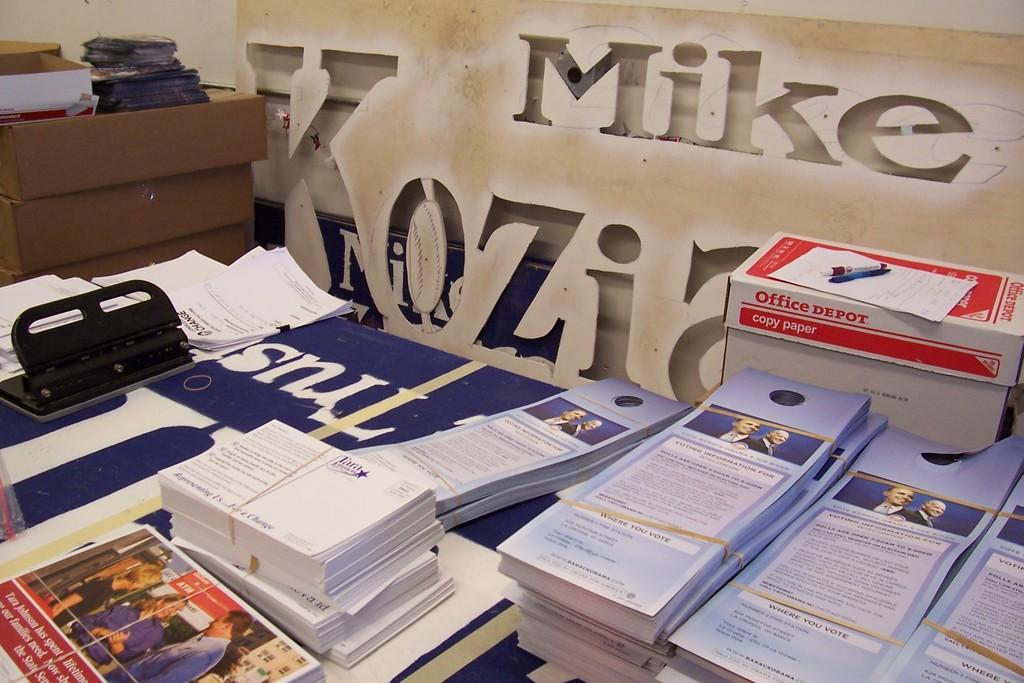<image>
Present a compact description of the photo's key features. a table for Mike Kozia with pamphlets and and Office Depot box 